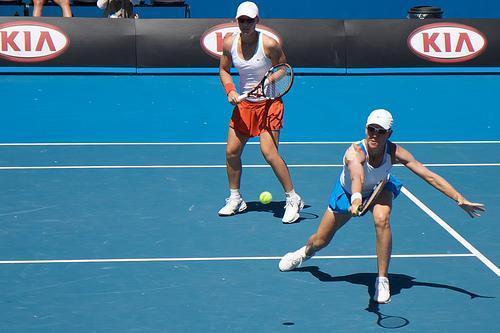How many players are in the photo?
Give a very brief answer. 2. 